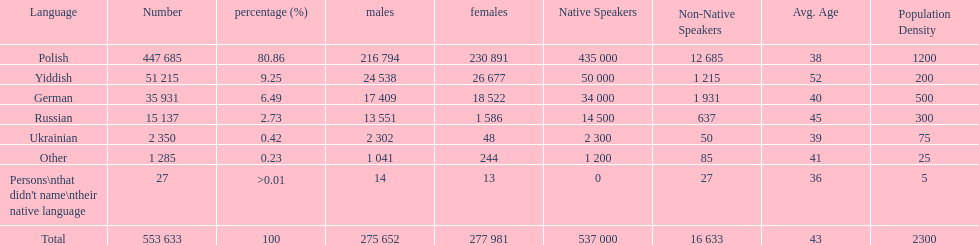Would you mind parsing the complete table? {'header': ['Language', 'Number', 'percentage (%)', 'males', 'females', 'Native Speakers', 'Non-Native Speakers', 'Avg. Age', 'Population Density'], 'rows': [['Polish', '447 685', '80.86', '216 794', '230 891', '435 000', '12 685', '38', '1200'], ['Yiddish', '51 215', '9.25', '24 538', '26 677', '50 000', '1 215', '52', '200'], ['German', '35 931', '6.49', '17 409', '18 522', '34 000', '1 931', '40', '500'], ['Russian', '15 137', '2.73', '13 551', '1 586', '14 500', '637', '45', '300'], ['Ukrainian', '2 350', '0.42', '2 302', '48', '2 300', '50', '39', '75'], ['Other', '1 285', '0.23', '1 041', '244', '1 200', '85', '41', '25'], ["Persons\\nthat didn't name\\ntheir native language", '27', '>0.01', '14', '13', '0', '27', '36', '5'], ['Total', '553 633', '100', '275 652', '277 981', '537 000', '16 633', '43', '2300']]} How many speakers (of any language) are represented on the table ? 553 633. 